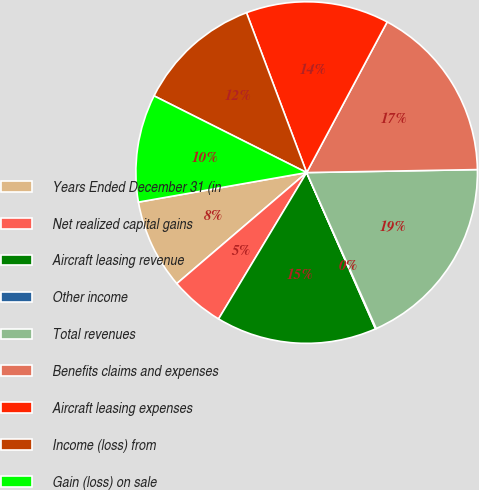Convert chart. <chart><loc_0><loc_0><loc_500><loc_500><pie_chart><fcel>Years Ended December 31 (in<fcel>Net realized capital gains<fcel>Aircraft leasing revenue<fcel>Other income<fcel>Total revenues<fcel>Benefits claims and expenses<fcel>Aircraft leasing expenses<fcel>Income (loss) from<fcel>Gain (loss) on sale<nl><fcel>8.49%<fcel>5.12%<fcel>15.23%<fcel>0.07%<fcel>18.6%<fcel>16.91%<fcel>13.54%<fcel>11.86%<fcel>10.18%<nl></chart> 